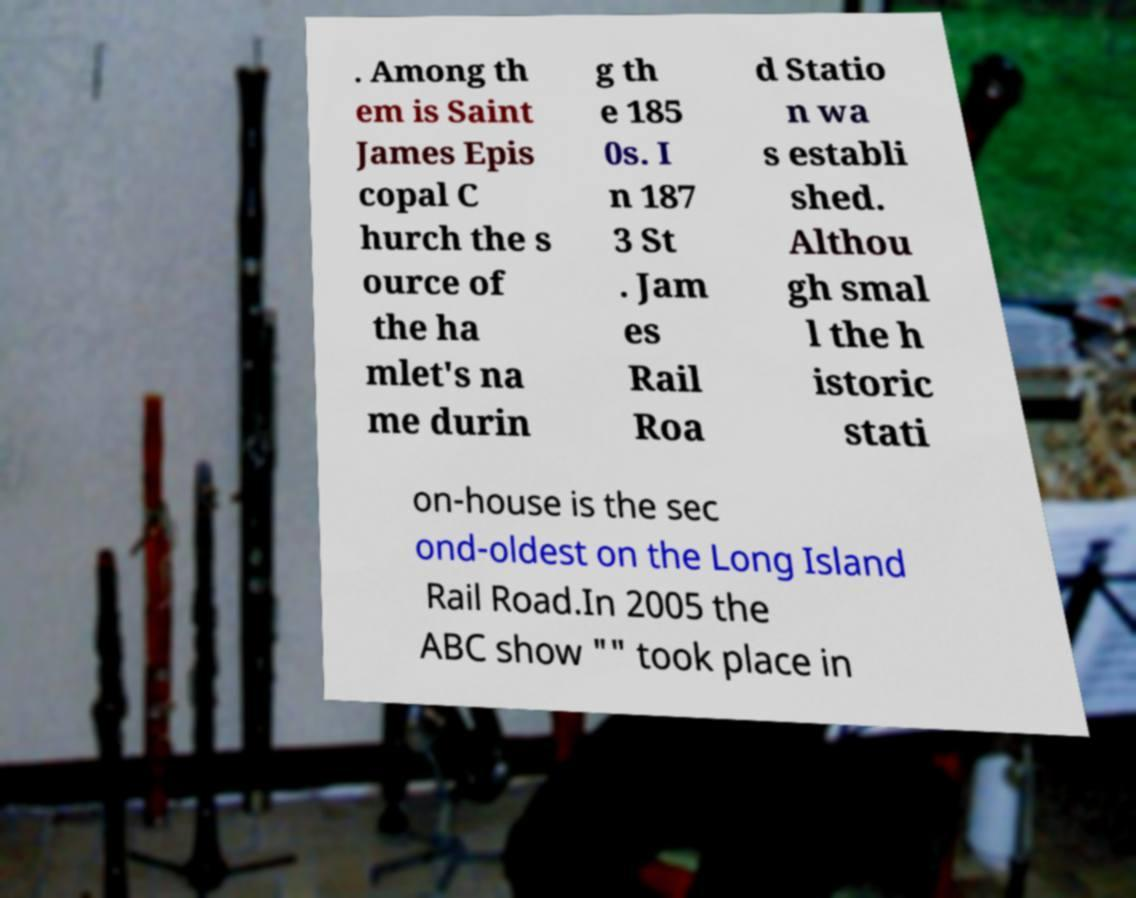What messages or text are displayed in this image? I need them in a readable, typed format. . Among th em is Saint James Epis copal C hurch the s ource of the ha mlet's na me durin g th e 185 0s. I n 187 3 St . Jam es Rail Roa d Statio n wa s establi shed. Althou gh smal l the h istoric stati on-house is the sec ond-oldest on the Long Island Rail Road.In 2005 the ABC show "" took place in 